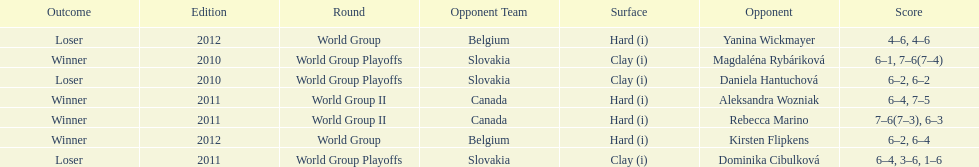What is the other year slovakia played besides 2010? 2011. 